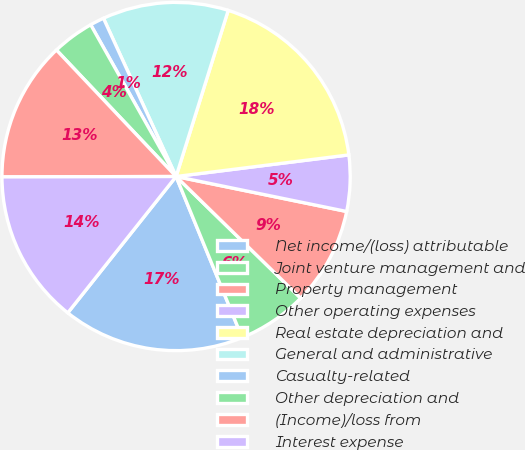Convert chart to OTSL. <chart><loc_0><loc_0><loc_500><loc_500><pie_chart><fcel>Net income/(loss) attributable<fcel>Joint venture management and<fcel>Property management<fcel>Other operating expenses<fcel>Real estate depreciation and<fcel>General and administrative<fcel>Casualty-related<fcel>Other depreciation and<fcel>(Income)/loss from<fcel>Interest expense<nl><fcel>16.88%<fcel>6.5%<fcel>9.09%<fcel>5.2%<fcel>18.18%<fcel>11.69%<fcel>1.31%<fcel>3.9%<fcel>12.98%<fcel>14.28%<nl></chart> 